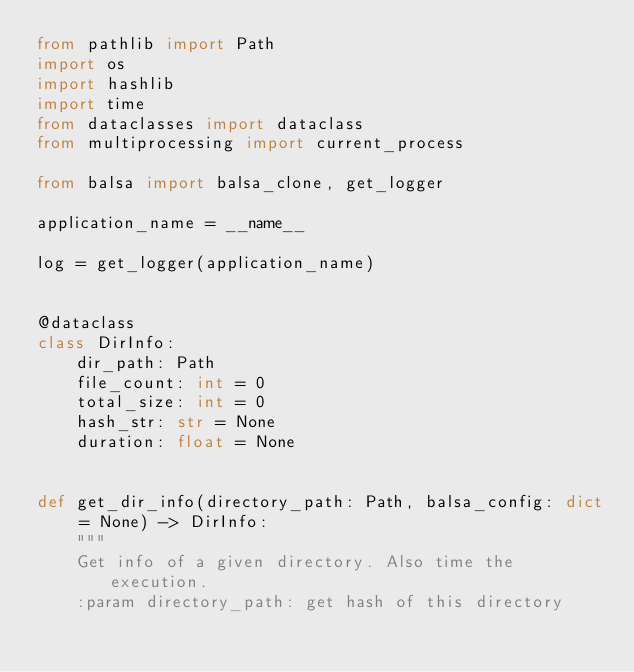Convert code to text. <code><loc_0><loc_0><loc_500><loc_500><_Python_>from pathlib import Path
import os
import hashlib
import time
from dataclasses import dataclass
from multiprocessing import current_process

from balsa import balsa_clone, get_logger

application_name = __name__

log = get_logger(application_name)


@dataclass
class DirInfo:
    dir_path: Path
    file_count: int = 0
    total_size: int = 0
    hash_str: str = None
    duration: float = None


def get_dir_info(directory_path: Path, balsa_config: dict = None) -> DirInfo:
    """
    Get info of a given directory. Also time the execution.
    :param directory_path: get hash of this directory</code> 